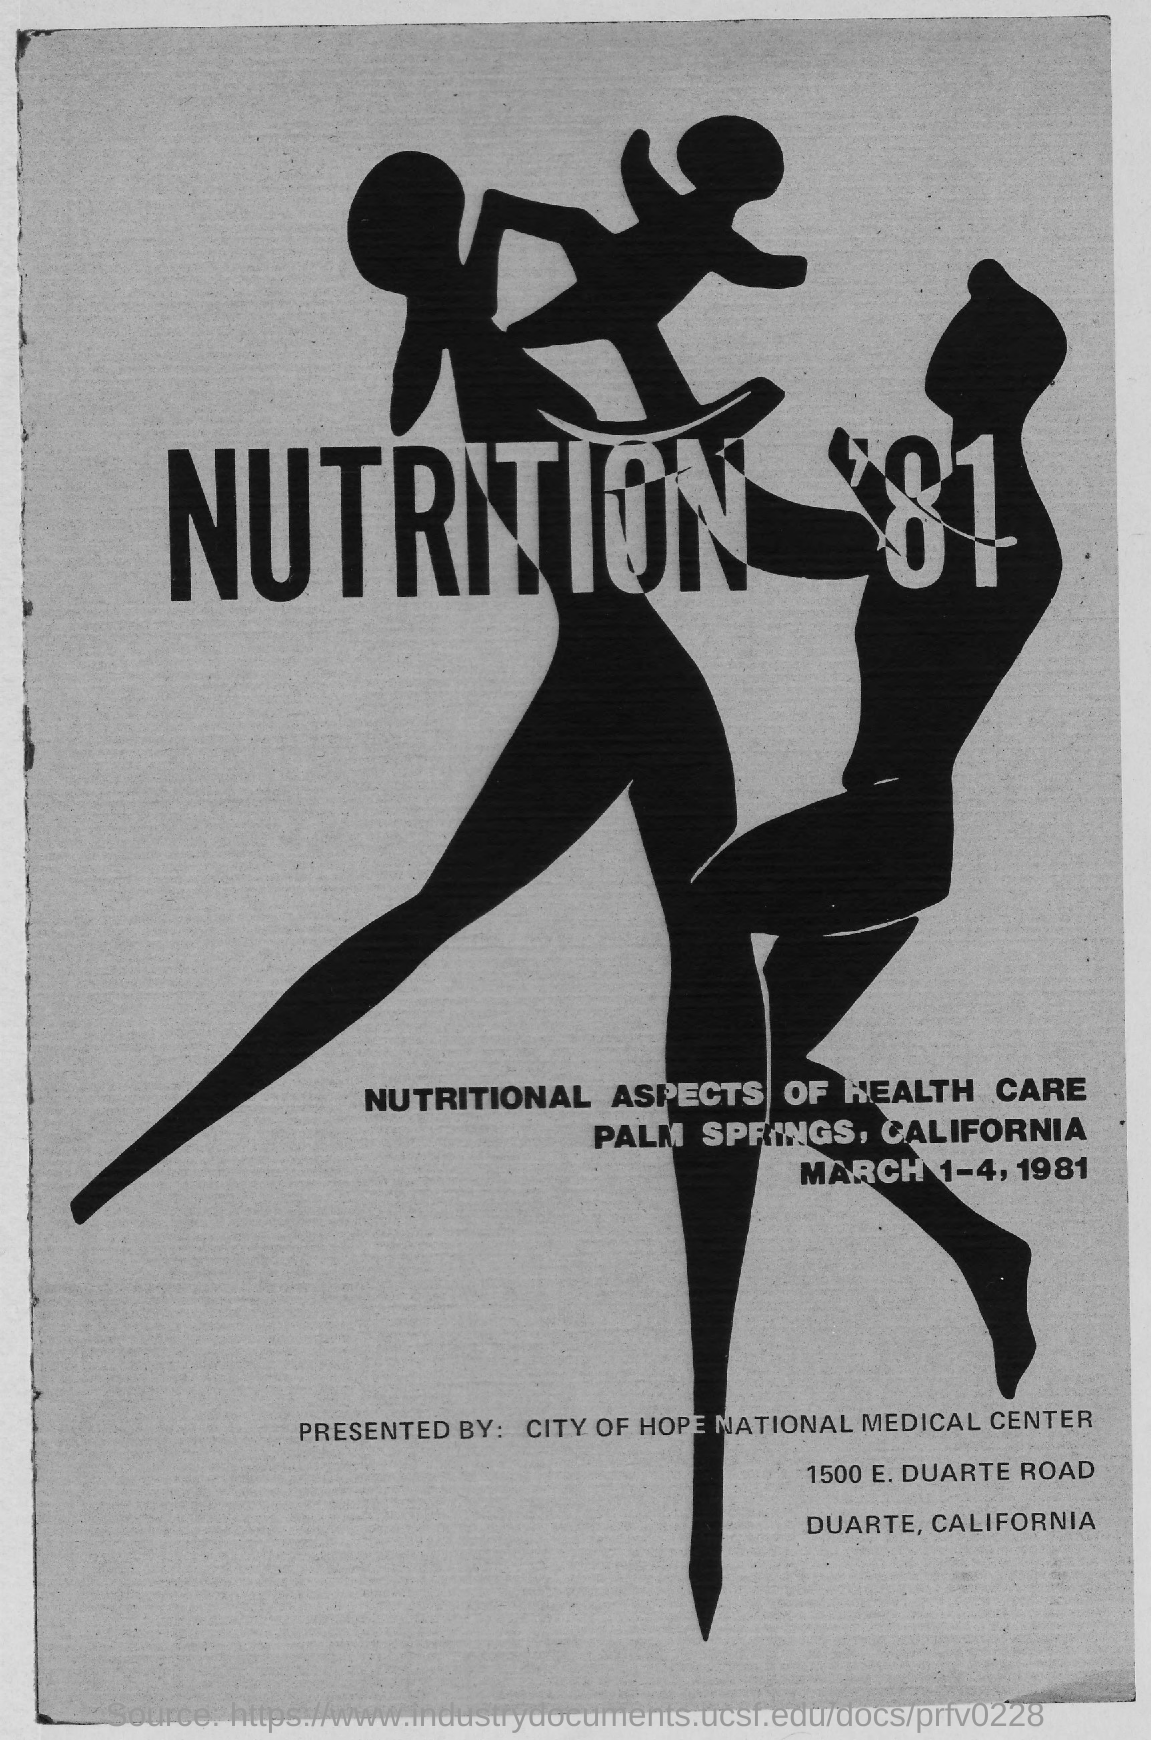Point out several critical features in this image. The event known as "NUTRITION '81" took place from March 1-4, 1981. The event "NUTRITION '81" was held in Palm Springs, California. The event 'NUTRITION '81 was presented by the City of Hope National Medical Center. 